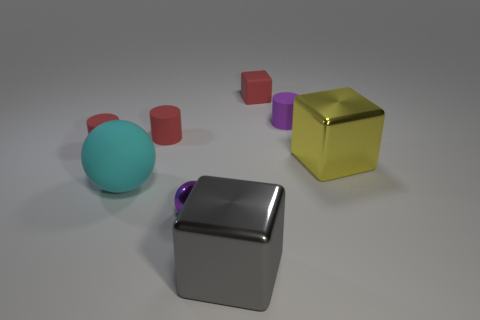There is a large thing that is the same shape as the small purple metal thing; what is it made of?
Offer a very short reply. Rubber. Are there fewer large yellow cubes that are behind the yellow metallic cube than small cylinders?
Your answer should be compact. Yes. There is a big yellow thing; how many red rubber cubes are to the left of it?
Provide a succinct answer. 1. Do the small object that is in front of the rubber sphere and the large thing left of the small purple shiny object have the same shape?
Provide a short and direct response. Yes. What shape is the object that is both on the left side of the big gray metallic cube and in front of the cyan matte object?
Your response must be concise. Sphere. What size is the purple thing that is the same material as the gray object?
Ensure brevity in your answer.  Small. Are there fewer small gray metal balls than metallic balls?
Provide a short and direct response. Yes. There is a yellow block on the right side of the tiny purple thing to the left of the purple object behind the yellow thing; what is it made of?
Make the answer very short. Metal. Is the tiny purple object on the right side of the tiny matte cube made of the same material as the small red thing that is on the right side of the gray metallic thing?
Offer a terse response. Yes. There is a metal object that is behind the big gray shiny object and on the left side of the large yellow metallic cube; how big is it?
Your response must be concise. Small. 